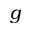Convert formula to latex. <formula><loc_0><loc_0><loc_500><loc_500>g</formula> 